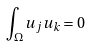<formula> <loc_0><loc_0><loc_500><loc_500>\int _ { \Omega } u _ { j } u _ { k } = 0</formula> 